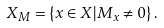Convert formula to latex. <formula><loc_0><loc_0><loc_500><loc_500>X _ { M } = \left \{ x \in X | M _ { x } \not = 0 \right \} .</formula> 